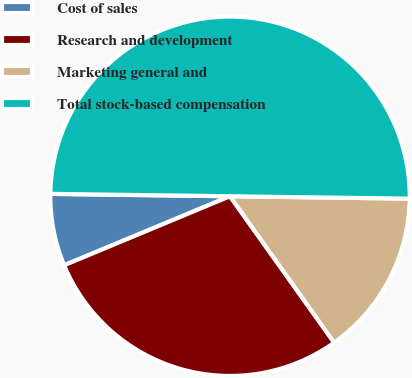Convert chart. <chart><loc_0><loc_0><loc_500><loc_500><pie_chart><fcel>Cost of sales<fcel>Research and development<fcel>Marketing general and<fcel>Total stock-based compensation<nl><fcel>6.49%<fcel>28.57%<fcel>14.94%<fcel>50.0%<nl></chart> 